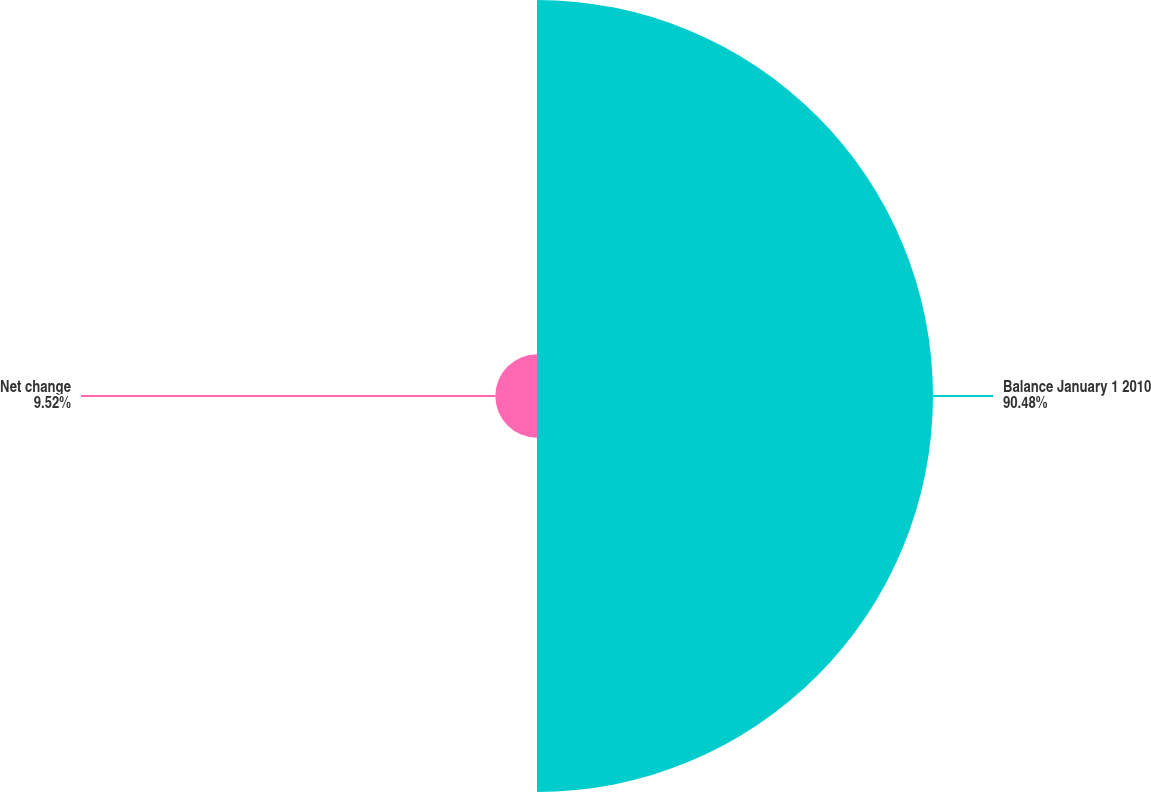<chart> <loc_0><loc_0><loc_500><loc_500><pie_chart><fcel>Balance January 1 2010<fcel>Net change<nl><fcel>90.48%<fcel>9.52%<nl></chart> 